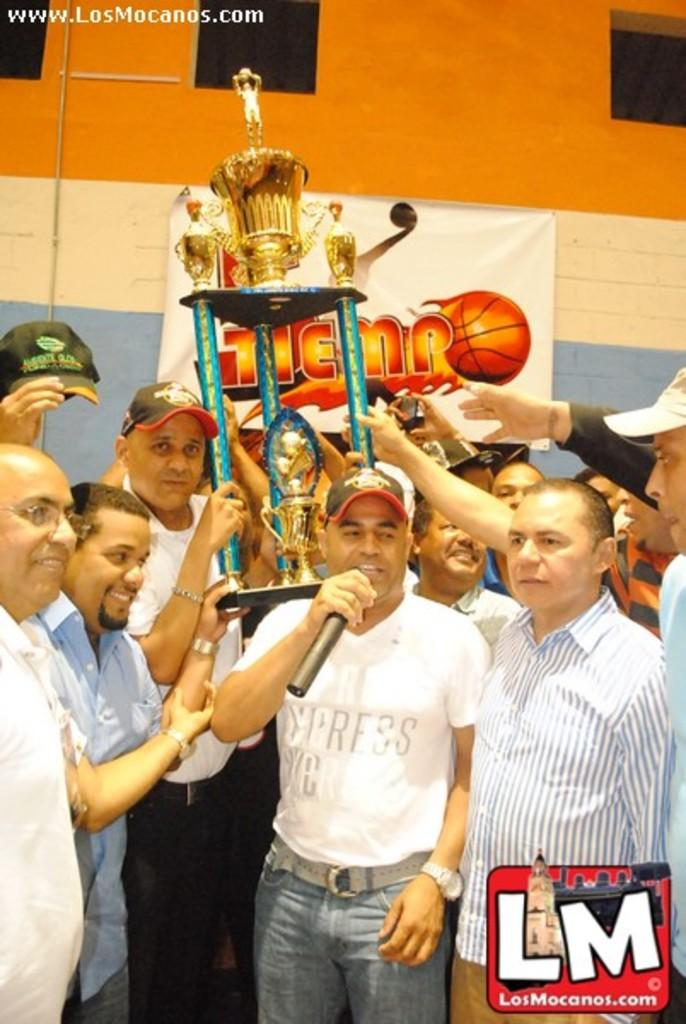What is happening in the image involving the group of people? One person is talking into a microphone, and all the people in the group are holding trophies. Can you describe the person using the microphone? The person using the microphone is likely making an announcement or giving a speech. What might the trophies signify in the image? The trophies might signify a recent victory or achievement by the group of people. How many oranges are being held by the people in the image? There are no oranges present in the image; the people are holding trophies. What type of disease is affecting the group of people in the image? There is no indication of any disease affecting the group of people in the image. 